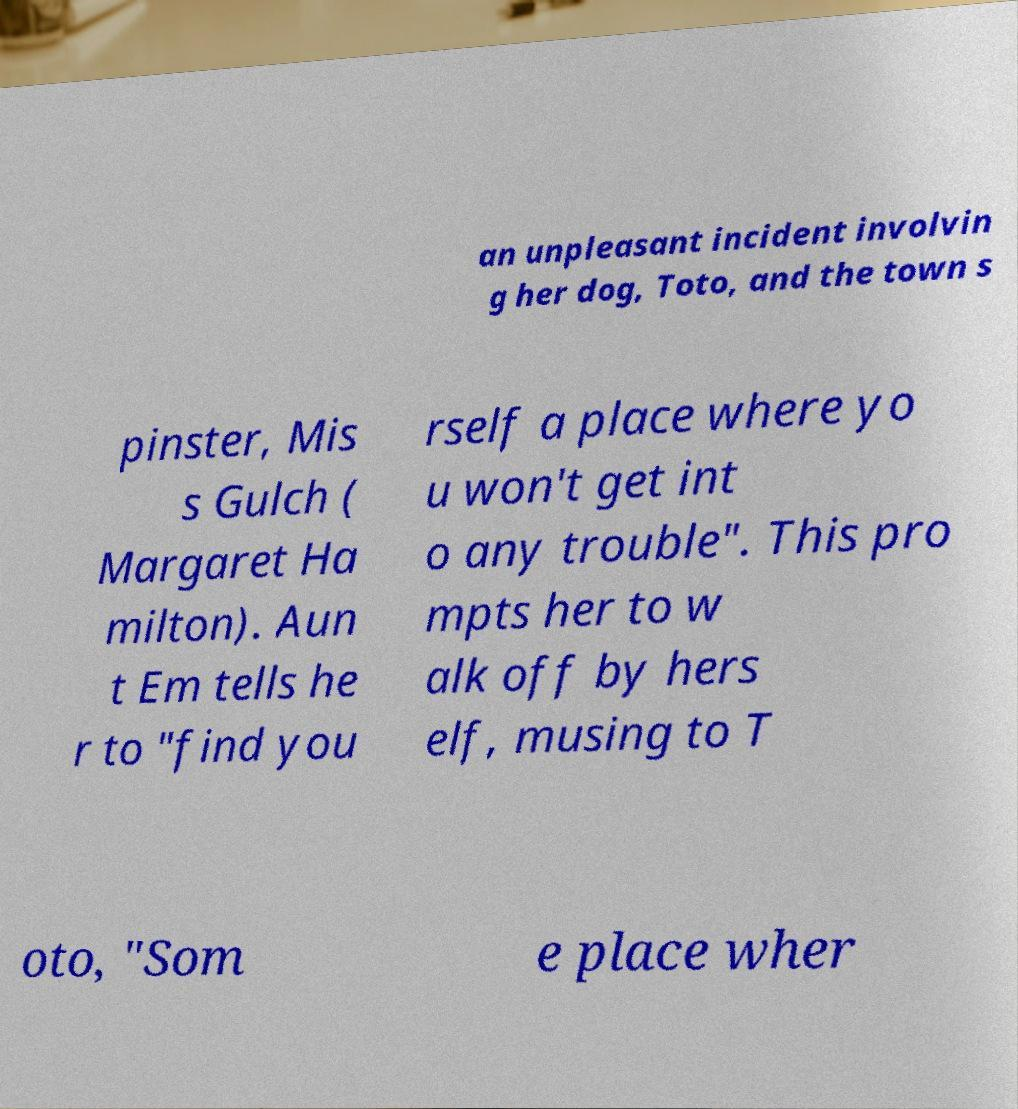There's text embedded in this image that I need extracted. Can you transcribe it verbatim? an unpleasant incident involvin g her dog, Toto, and the town s pinster, Mis s Gulch ( Margaret Ha milton). Aun t Em tells he r to "find you rself a place where yo u won't get int o any trouble". This pro mpts her to w alk off by hers elf, musing to T oto, "Som e place wher 